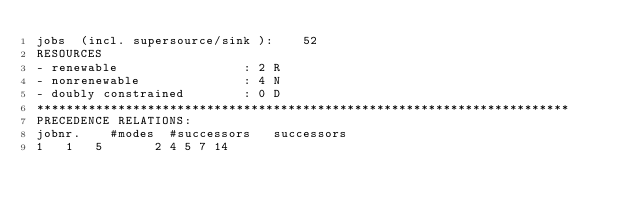<code> <loc_0><loc_0><loc_500><loc_500><_ObjectiveC_>jobs  (incl. supersource/sink ):	52
RESOURCES
- renewable                 : 2 R
- nonrenewable              : 4 N
- doubly constrained        : 0 D
************************************************************************
PRECEDENCE RELATIONS:
jobnr.    #modes  #successors   successors
1	1	5		2 4 5 7 14 </code> 